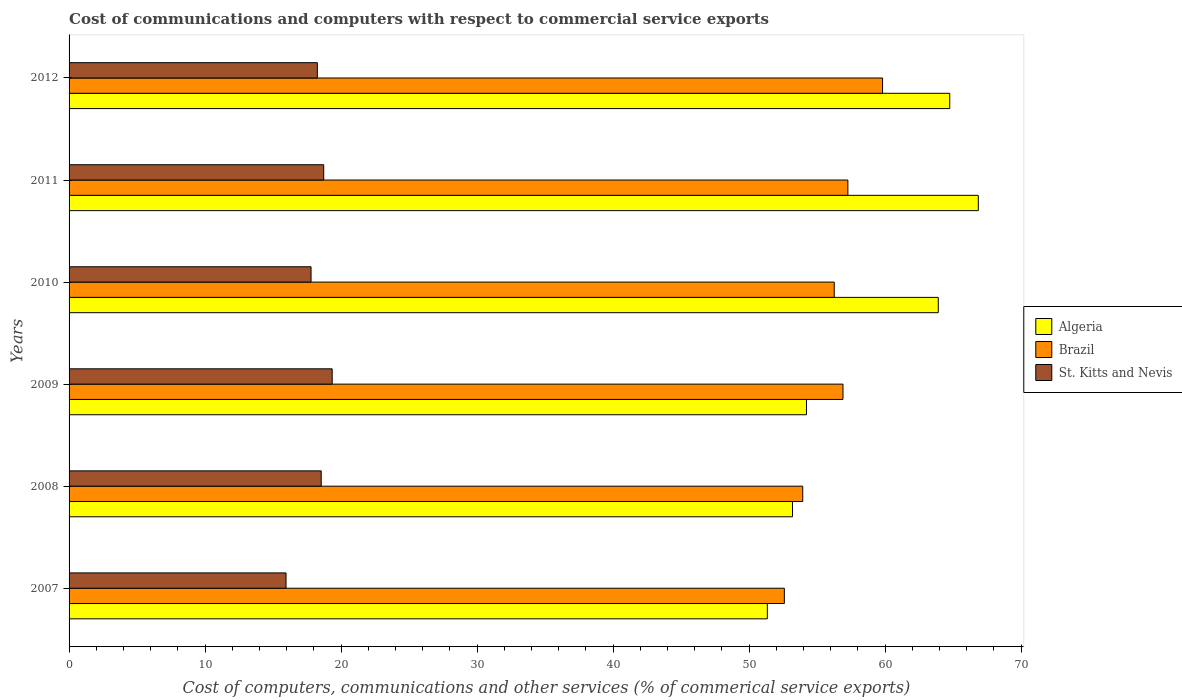How many groups of bars are there?
Ensure brevity in your answer.  6. How many bars are there on the 3rd tick from the bottom?
Make the answer very short. 3. What is the label of the 5th group of bars from the top?
Provide a short and direct response. 2008. What is the cost of communications and computers in St. Kitts and Nevis in 2011?
Your response must be concise. 18.72. Across all years, what is the maximum cost of communications and computers in Brazil?
Make the answer very short. 59.81. Across all years, what is the minimum cost of communications and computers in Brazil?
Your answer should be very brief. 52.59. What is the total cost of communications and computers in Brazil in the graph?
Give a very brief answer. 336.75. What is the difference between the cost of communications and computers in Algeria in 2007 and that in 2012?
Your answer should be very brief. -13.41. What is the difference between the cost of communications and computers in Algeria in 2011 and the cost of communications and computers in St. Kitts and Nevis in 2008?
Your answer should be very brief. 48.31. What is the average cost of communications and computers in St. Kitts and Nevis per year?
Make the answer very short. 18.1. In the year 2010, what is the difference between the cost of communications and computers in Brazil and cost of communications and computers in St. Kitts and Nevis?
Provide a short and direct response. 38.46. In how many years, is the cost of communications and computers in St. Kitts and Nevis greater than 60 %?
Your answer should be compact. 0. What is the ratio of the cost of communications and computers in St. Kitts and Nevis in 2008 to that in 2010?
Keep it short and to the point. 1.04. Is the cost of communications and computers in Algeria in 2010 less than that in 2012?
Make the answer very short. Yes. Is the difference between the cost of communications and computers in Brazil in 2007 and 2009 greater than the difference between the cost of communications and computers in St. Kitts and Nevis in 2007 and 2009?
Offer a terse response. No. What is the difference between the highest and the second highest cost of communications and computers in St. Kitts and Nevis?
Your answer should be very brief. 0.62. What is the difference between the highest and the lowest cost of communications and computers in Brazil?
Keep it short and to the point. 7.22. In how many years, is the cost of communications and computers in Brazil greater than the average cost of communications and computers in Brazil taken over all years?
Provide a succinct answer. 4. Is the sum of the cost of communications and computers in Algeria in 2010 and 2012 greater than the maximum cost of communications and computers in St. Kitts and Nevis across all years?
Provide a succinct answer. Yes. What does the 3rd bar from the top in 2010 represents?
Offer a terse response. Algeria. What does the 1st bar from the bottom in 2009 represents?
Provide a short and direct response. Algeria. Is it the case that in every year, the sum of the cost of communications and computers in Brazil and cost of communications and computers in St. Kitts and Nevis is greater than the cost of communications and computers in Algeria?
Ensure brevity in your answer.  Yes. Are all the bars in the graph horizontal?
Give a very brief answer. Yes. Are the values on the major ticks of X-axis written in scientific E-notation?
Give a very brief answer. No. Does the graph contain any zero values?
Offer a terse response. No. Does the graph contain grids?
Your response must be concise. No. Where does the legend appear in the graph?
Your answer should be very brief. Center right. What is the title of the graph?
Your answer should be very brief. Cost of communications and computers with respect to commercial service exports. Does "Small states" appear as one of the legend labels in the graph?
Offer a terse response. No. What is the label or title of the X-axis?
Give a very brief answer. Cost of computers, communications and other services (% of commerical service exports). What is the label or title of the Y-axis?
Keep it short and to the point. Years. What is the Cost of computers, communications and other services (% of commerical service exports) in Algeria in 2007?
Offer a terse response. 51.34. What is the Cost of computers, communications and other services (% of commerical service exports) in Brazil in 2007?
Offer a terse response. 52.59. What is the Cost of computers, communications and other services (% of commerical service exports) in St. Kitts and Nevis in 2007?
Provide a succinct answer. 15.95. What is the Cost of computers, communications and other services (% of commerical service exports) of Algeria in 2008?
Keep it short and to the point. 53.19. What is the Cost of computers, communications and other services (% of commerical service exports) in Brazil in 2008?
Offer a very short reply. 53.94. What is the Cost of computers, communications and other services (% of commerical service exports) in St. Kitts and Nevis in 2008?
Give a very brief answer. 18.54. What is the Cost of computers, communications and other services (% of commerical service exports) of Algeria in 2009?
Your answer should be very brief. 54.21. What is the Cost of computers, communications and other services (% of commerical service exports) of Brazil in 2009?
Ensure brevity in your answer.  56.9. What is the Cost of computers, communications and other services (% of commerical service exports) in St. Kitts and Nevis in 2009?
Your response must be concise. 19.34. What is the Cost of computers, communications and other services (% of commerical service exports) of Algeria in 2010?
Keep it short and to the point. 63.9. What is the Cost of computers, communications and other services (% of commerical service exports) of Brazil in 2010?
Provide a short and direct response. 56.25. What is the Cost of computers, communications and other services (% of commerical service exports) in St. Kitts and Nevis in 2010?
Provide a succinct answer. 17.79. What is the Cost of computers, communications and other services (% of commerical service exports) in Algeria in 2011?
Your answer should be very brief. 66.85. What is the Cost of computers, communications and other services (% of commerical service exports) of Brazil in 2011?
Your answer should be very brief. 57.26. What is the Cost of computers, communications and other services (% of commerical service exports) in St. Kitts and Nevis in 2011?
Your response must be concise. 18.72. What is the Cost of computers, communications and other services (% of commerical service exports) in Algeria in 2012?
Your response must be concise. 64.75. What is the Cost of computers, communications and other services (% of commerical service exports) of Brazil in 2012?
Provide a succinct answer. 59.81. What is the Cost of computers, communications and other services (% of commerical service exports) in St. Kitts and Nevis in 2012?
Provide a short and direct response. 18.25. Across all years, what is the maximum Cost of computers, communications and other services (% of commerical service exports) in Algeria?
Ensure brevity in your answer.  66.85. Across all years, what is the maximum Cost of computers, communications and other services (% of commerical service exports) in Brazil?
Offer a terse response. 59.81. Across all years, what is the maximum Cost of computers, communications and other services (% of commerical service exports) in St. Kitts and Nevis?
Your answer should be very brief. 19.34. Across all years, what is the minimum Cost of computers, communications and other services (% of commerical service exports) in Algeria?
Make the answer very short. 51.34. Across all years, what is the minimum Cost of computers, communications and other services (% of commerical service exports) of Brazil?
Offer a terse response. 52.59. Across all years, what is the minimum Cost of computers, communications and other services (% of commerical service exports) of St. Kitts and Nevis?
Keep it short and to the point. 15.95. What is the total Cost of computers, communications and other services (% of commerical service exports) in Algeria in the graph?
Keep it short and to the point. 354.23. What is the total Cost of computers, communications and other services (% of commerical service exports) of Brazil in the graph?
Give a very brief answer. 336.75. What is the total Cost of computers, communications and other services (% of commerical service exports) of St. Kitts and Nevis in the graph?
Provide a short and direct response. 108.6. What is the difference between the Cost of computers, communications and other services (% of commerical service exports) of Algeria in 2007 and that in 2008?
Make the answer very short. -1.85. What is the difference between the Cost of computers, communications and other services (% of commerical service exports) of Brazil in 2007 and that in 2008?
Offer a very short reply. -1.35. What is the difference between the Cost of computers, communications and other services (% of commerical service exports) of St. Kitts and Nevis in 2007 and that in 2008?
Ensure brevity in your answer.  -2.59. What is the difference between the Cost of computers, communications and other services (% of commerical service exports) in Algeria in 2007 and that in 2009?
Give a very brief answer. -2.88. What is the difference between the Cost of computers, communications and other services (% of commerical service exports) of Brazil in 2007 and that in 2009?
Ensure brevity in your answer.  -4.31. What is the difference between the Cost of computers, communications and other services (% of commerical service exports) in St. Kitts and Nevis in 2007 and that in 2009?
Provide a succinct answer. -3.39. What is the difference between the Cost of computers, communications and other services (% of commerical service exports) in Algeria in 2007 and that in 2010?
Make the answer very short. -12.57. What is the difference between the Cost of computers, communications and other services (% of commerical service exports) of Brazil in 2007 and that in 2010?
Give a very brief answer. -3.67. What is the difference between the Cost of computers, communications and other services (% of commerical service exports) in St. Kitts and Nevis in 2007 and that in 2010?
Offer a very short reply. -1.84. What is the difference between the Cost of computers, communications and other services (% of commerical service exports) in Algeria in 2007 and that in 2011?
Your answer should be compact. -15.51. What is the difference between the Cost of computers, communications and other services (% of commerical service exports) in Brazil in 2007 and that in 2011?
Provide a short and direct response. -4.67. What is the difference between the Cost of computers, communications and other services (% of commerical service exports) of St. Kitts and Nevis in 2007 and that in 2011?
Provide a short and direct response. -2.77. What is the difference between the Cost of computers, communications and other services (% of commerical service exports) of Algeria in 2007 and that in 2012?
Offer a very short reply. -13.41. What is the difference between the Cost of computers, communications and other services (% of commerical service exports) of Brazil in 2007 and that in 2012?
Keep it short and to the point. -7.22. What is the difference between the Cost of computers, communications and other services (% of commerical service exports) of St. Kitts and Nevis in 2007 and that in 2012?
Keep it short and to the point. -2.3. What is the difference between the Cost of computers, communications and other services (% of commerical service exports) in Algeria in 2008 and that in 2009?
Your answer should be compact. -1.03. What is the difference between the Cost of computers, communications and other services (% of commerical service exports) of Brazil in 2008 and that in 2009?
Offer a very short reply. -2.96. What is the difference between the Cost of computers, communications and other services (% of commerical service exports) of St. Kitts and Nevis in 2008 and that in 2009?
Your answer should be compact. -0.81. What is the difference between the Cost of computers, communications and other services (% of commerical service exports) in Algeria in 2008 and that in 2010?
Give a very brief answer. -10.72. What is the difference between the Cost of computers, communications and other services (% of commerical service exports) of Brazil in 2008 and that in 2010?
Your answer should be compact. -2.32. What is the difference between the Cost of computers, communications and other services (% of commerical service exports) of St. Kitts and Nevis in 2008 and that in 2010?
Keep it short and to the point. 0.75. What is the difference between the Cost of computers, communications and other services (% of commerical service exports) in Algeria in 2008 and that in 2011?
Give a very brief answer. -13.66. What is the difference between the Cost of computers, communications and other services (% of commerical service exports) in Brazil in 2008 and that in 2011?
Ensure brevity in your answer.  -3.32. What is the difference between the Cost of computers, communications and other services (% of commerical service exports) of St. Kitts and Nevis in 2008 and that in 2011?
Your answer should be very brief. -0.18. What is the difference between the Cost of computers, communications and other services (% of commerical service exports) in Algeria in 2008 and that in 2012?
Your response must be concise. -11.56. What is the difference between the Cost of computers, communications and other services (% of commerical service exports) in Brazil in 2008 and that in 2012?
Ensure brevity in your answer.  -5.87. What is the difference between the Cost of computers, communications and other services (% of commerical service exports) of St. Kitts and Nevis in 2008 and that in 2012?
Give a very brief answer. 0.29. What is the difference between the Cost of computers, communications and other services (% of commerical service exports) of Algeria in 2009 and that in 2010?
Your answer should be compact. -9.69. What is the difference between the Cost of computers, communications and other services (% of commerical service exports) in Brazil in 2009 and that in 2010?
Your answer should be compact. 0.64. What is the difference between the Cost of computers, communications and other services (% of commerical service exports) of St. Kitts and Nevis in 2009 and that in 2010?
Offer a very short reply. 1.55. What is the difference between the Cost of computers, communications and other services (% of commerical service exports) of Algeria in 2009 and that in 2011?
Offer a terse response. -12.63. What is the difference between the Cost of computers, communications and other services (% of commerical service exports) in Brazil in 2009 and that in 2011?
Offer a terse response. -0.36. What is the difference between the Cost of computers, communications and other services (% of commerical service exports) in St. Kitts and Nevis in 2009 and that in 2011?
Give a very brief answer. 0.62. What is the difference between the Cost of computers, communications and other services (% of commerical service exports) of Algeria in 2009 and that in 2012?
Make the answer very short. -10.53. What is the difference between the Cost of computers, communications and other services (% of commerical service exports) in Brazil in 2009 and that in 2012?
Offer a terse response. -2.91. What is the difference between the Cost of computers, communications and other services (% of commerical service exports) in St. Kitts and Nevis in 2009 and that in 2012?
Your answer should be compact. 1.09. What is the difference between the Cost of computers, communications and other services (% of commerical service exports) in Algeria in 2010 and that in 2011?
Your answer should be very brief. -2.94. What is the difference between the Cost of computers, communications and other services (% of commerical service exports) in Brazil in 2010 and that in 2011?
Keep it short and to the point. -1. What is the difference between the Cost of computers, communications and other services (% of commerical service exports) in St. Kitts and Nevis in 2010 and that in 2011?
Offer a very short reply. -0.93. What is the difference between the Cost of computers, communications and other services (% of commerical service exports) of Algeria in 2010 and that in 2012?
Your response must be concise. -0.84. What is the difference between the Cost of computers, communications and other services (% of commerical service exports) in Brazil in 2010 and that in 2012?
Your answer should be compact. -3.55. What is the difference between the Cost of computers, communications and other services (% of commerical service exports) in St. Kitts and Nevis in 2010 and that in 2012?
Keep it short and to the point. -0.46. What is the difference between the Cost of computers, communications and other services (% of commerical service exports) in Algeria in 2011 and that in 2012?
Your answer should be very brief. 2.1. What is the difference between the Cost of computers, communications and other services (% of commerical service exports) of Brazil in 2011 and that in 2012?
Offer a very short reply. -2.55. What is the difference between the Cost of computers, communications and other services (% of commerical service exports) in St. Kitts and Nevis in 2011 and that in 2012?
Your answer should be compact. 0.47. What is the difference between the Cost of computers, communications and other services (% of commerical service exports) in Algeria in 2007 and the Cost of computers, communications and other services (% of commerical service exports) in Brazil in 2008?
Keep it short and to the point. -2.6. What is the difference between the Cost of computers, communications and other services (% of commerical service exports) of Algeria in 2007 and the Cost of computers, communications and other services (% of commerical service exports) of St. Kitts and Nevis in 2008?
Ensure brevity in your answer.  32.8. What is the difference between the Cost of computers, communications and other services (% of commerical service exports) in Brazil in 2007 and the Cost of computers, communications and other services (% of commerical service exports) in St. Kitts and Nevis in 2008?
Provide a succinct answer. 34.05. What is the difference between the Cost of computers, communications and other services (% of commerical service exports) in Algeria in 2007 and the Cost of computers, communications and other services (% of commerical service exports) in Brazil in 2009?
Give a very brief answer. -5.56. What is the difference between the Cost of computers, communications and other services (% of commerical service exports) of Algeria in 2007 and the Cost of computers, communications and other services (% of commerical service exports) of St. Kitts and Nevis in 2009?
Your answer should be very brief. 31.99. What is the difference between the Cost of computers, communications and other services (% of commerical service exports) of Brazil in 2007 and the Cost of computers, communications and other services (% of commerical service exports) of St. Kitts and Nevis in 2009?
Keep it short and to the point. 33.24. What is the difference between the Cost of computers, communications and other services (% of commerical service exports) in Algeria in 2007 and the Cost of computers, communications and other services (% of commerical service exports) in Brazil in 2010?
Make the answer very short. -4.92. What is the difference between the Cost of computers, communications and other services (% of commerical service exports) of Algeria in 2007 and the Cost of computers, communications and other services (% of commerical service exports) of St. Kitts and Nevis in 2010?
Provide a succinct answer. 33.55. What is the difference between the Cost of computers, communications and other services (% of commerical service exports) of Brazil in 2007 and the Cost of computers, communications and other services (% of commerical service exports) of St. Kitts and Nevis in 2010?
Ensure brevity in your answer.  34.8. What is the difference between the Cost of computers, communications and other services (% of commerical service exports) in Algeria in 2007 and the Cost of computers, communications and other services (% of commerical service exports) in Brazil in 2011?
Your answer should be very brief. -5.92. What is the difference between the Cost of computers, communications and other services (% of commerical service exports) in Algeria in 2007 and the Cost of computers, communications and other services (% of commerical service exports) in St. Kitts and Nevis in 2011?
Make the answer very short. 32.61. What is the difference between the Cost of computers, communications and other services (% of commerical service exports) of Brazil in 2007 and the Cost of computers, communications and other services (% of commerical service exports) of St. Kitts and Nevis in 2011?
Your response must be concise. 33.87. What is the difference between the Cost of computers, communications and other services (% of commerical service exports) in Algeria in 2007 and the Cost of computers, communications and other services (% of commerical service exports) in Brazil in 2012?
Provide a short and direct response. -8.47. What is the difference between the Cost of computers, communications and other services (% of commerical service exports) of Algeria in 2007 and the Cost of computers, communications and other services (% of commerical service exports) of St. Kitts and Nevis in 2012?
Offer a very short reply. 33.08. What is the difference between the Cost of computers, communications and other services (% of commerical service exports) of Brazil in 2007 and the Cost of computers, communications and other services (% of commerical service exports) of St. Kitts and Nevis in 2012?
Your response must be concise. 34.34. What is the difference between the Cost of computers, communications and other services (% of commerical service exports) of Algeria in 2008 and the Cost of computers, communications and other services (% of commerical service exports) of Brazil in 2009?
Your answer should be compact. -3.71. What is the difference between the Cost of computers, communications and other services (% of commerical service exports) of Algeria in 2008 and the Cost of computers, communications and other services (% of commerical service exports) of St. Kitts and Nevis in 2009?
Make the answer very short. 33.84. What is the difference between the Cost of computers, communications and other services (% of commerical service exports) in Brazil in 2008 and the Cost of computers, communications and other services (% of commerical service exports) in St. Kitts and Nevis in 2009?
Offer a very short reply. 34.6. What is the difference between the Cost of computers, communications and other services (% of commerical service exports) in Algeria in 2008 and the Cost of computers, communications and other services (% of commerical service exports) in Brazil in 2010?
Ensure brevity in your answer.  -3.07. What is the difference between the Cost of computers, communications and other services (% of commerical service exports) in Algeria in 2008 and the Cost of computers, communications and other services (% of commerical service exports) in St. Kitts and Nevis in 2010?
Offer a terse response. 35.4. What is the difference between the Cost of computers, communications and other services (% of commerical service exports) in Brazil in 2008 and the Cost of computers, communications and other services (% of commerical service exports) in St. Kitts and Nevis in 2010?
Offer a terse response. 36.15. What is the difference between the Cost of computers, communications and other services (% of commerical service exports) of Algeria in 2008 and the Cost of computers, communications and other services (% of commerical service exports) of Brazil in 2011?
Offer a very short reply. -4.07. What is the difference between the Cost of computers, communications and other services (% of commerical service exports) in Algeria in 2008 and the Cost of computers, communications and other services (% of commerical service exports) in St. Kitts and Nevis in 2011?
Provide a short and direct response. 34.46. What is the difference between the Cost of computers, communications and other services (% of commerical service exports) of Brazil in 2008 and the Cost of computers, communications and other services (% of commerical service exports) of St. Kitts and Nevis in 2011?
Offer a very short reply. 35.22. What is the difference between the Cost of computers, communications and other services (% of commerical service exports) in Algeria in 2008 and the Cost of computers, communications and other services (% of commerical service exports) in Brazil in 2012?
Keep it short and to the point. -6.62. What is the difference between the Cost of computers, communications and other services (% of commerical service exports) of Algeria in 2008 and the Cost of computers, communications and other services (% of commerical service exports) of St. Kitts and Nevis in 2012?
Keep it short and to the point. 34.93. What is the difference between the Cost of computers, communications and other services (% of commerical service exports) of Brazil in 2008 and the Cost of computers, communications and other services (% of commerical service exports) of St. Kitts and Nevis in 2012?
Your response must be concise. 35.69. What is the difference between the Cost of computers, communications and other services (% of commerical service exports) in Algeria in 2009 and the Cost of computers, communications and other services (% of commerical service exports) in Brazil in 2010?
Your answer should be compact. -2.04. What is the difference between the Cost of computers, communications and other services (% of commerical service exports) of Algeria in 2009 and the Cost of computers, communications and other services (% of commerical service exports) of St. Kitts and Nevis in 2010?
Your answer should be compact. 36.42. What is the difference between the Cost of computers, communications and other services (% of commerical service exports) of Brazil in 2009 and the Cost of computers, communications and other services (% of commerical service exports) of St. Kitts and Nevis in 2010?
Provide a short and direct response. 39.11. What is the difference between the Cost of computers, communications and other services (% of commerical service exports) of Algeria in 2009 and the Cost of computers, communications and other services (% of commerical service exports) of Brazil in 2011?
Offer a very short reply. -3.04. What is the difference between the Cost of computers, communications and other services (% of commerical service exports) in Algeria in 2009 and the Cost of computers, communications and other services (% of commerical service exports) in St. Kitts and Nevis in 2011?
Your answer should be very brief. 35.49. What is the difference between the Cost of computers, communications and other services (% of commerical service exports) in Brazil in 2009 and the Cost of computers, communications and other services (% of commerical service exports) in St. Kitts and Nevis in 2011?
Make the answer very short. 38.18. What is the difference between the Cost of computers, communications and other services (% of commerical service exports) of Algeria in 2009 and the Cost of computers, communications and other services (% of commerical service exports) of Brazil in 2012?
Your answer should be compact. -5.6. What is the difference between the Cost of computers, communications and other services (% of commerical service exports) of Algeria in 2009 and the Cost of computers, communications and other services (% of commerical service exports) of St. Kitts and Nevis in 2012?
Offer a very short reply. 35.96. What is the difference between the Cost of computers, communications and other services (% of commerical service exports) in Brazil in 2009 and the Cost of computers, communications and other services (% of commerical service exports) in St. Kitts and Nevis in 2012?
Your answer should be compact. 38.65. What is the difference between the Cost of computers, communications and other services (% of commerical service exports) of Algeria in 2010 and the Cost of computers, communications and other services (% of commerical service exports) of Brazil in 2011?
Give a very brief answer. 6.65. What is the difference between the Cost of computers, communications and other services (% of commerical service exports) of Algeria in 2010 and the Cost of computers, communications and other services (% of commerical service exports) of St. Kitts and Nevis in 2011?
Ensure brevity in your answer.  45.18. What is the difference between the Cost of computers, communications and other services (% of commerical service exports) in Brazil in 2010 and the Cost of computers, communications and other services (% of commerical service exports) in St. Kitts and Nevis in 2011?
Provide a succinct answer. 37.53. What is the difference between the Cost of computers, communications and other services (% of commerical service exports) of Algeria in 2010 and the Cost of computers, communications and other services (% of commerical service exports) of Brazil in 2012?
Offer a terse response. 4.1. What is the difference between the Cost of computers, communications and other services (% of commerical service exports) in Algeria in 2010 and the Cost of computers, communications and other services (% of commerical service exports) in St. Kitts and Nevis in 2012?
Your answer should be very brief. 45.65. What is the difference between the Cost of computers, communications and other services (% of commerical service exports) of Brazil in 2010 and the Cost of computers, communications and other services (% of commerical service exports) of St. Kitts and Nevis in 2012?
Your answer should be compact. 38. What is the difference between the Cost of computers, communications and other services (% of commerical service exports) in Algeria in 2011 and the Cost of computers, communications and other services (% of commerical service exports) in Brazil in 2012?
Make the answer very short. 7.04. What is the difference between the Cost of computers, communications and other services (% of commerical service exports) in Algeria in 2011 and the Cost of computers, communications and other services (% of commerical service exports) in St. Kitts and Nevis in 2012?
Give a very brief answer. 48.6. What is the difference between the Cost of computers, communications and other services (% of commerical service exports) of Brazil in 2011 and the Cost of computers, communications and other services (% of commerical service exports) of St. Kitts and Nevis in 2012?
Your answer should be very brief. 39.01. What is the average Cost of computers, communications and other services (% of commerical service exports) in Algeria per year?
Offer a terse response. 59.04. What is the average Cost of computers, communications and other services (% of commerical service exports) in Brazil per year?
Ensure brevity in your answer.  56.12. What is the average Cost of computers, communications and other services (% of commerical service exports) of St. Kitts and Nevis per year?
Give a very brief answer. 18.1. In the year 2007, what is the difference between the Cost of computers, communications and other services (% of commerical service exports) in Algeria and Cost of computers, communications and other services (% of commerical service exports) in Brazil?
Make the answer very short. -1.25. In the year 2007, what is the difference between the Cost of computers, communications and other services (% of commerical service exports) of Algeria and Cost of computers, communications and other services (% of commerical service exports) of St. Kitts and Nevis?
Provide a short and direct response. 35.38. In the year 2007, what is the difference between the Cost of computers, communications and other services (% of commerical service exports) in Brazil and Cost of computers, communications and other services (% of commerical service exports) in St. Kitts and Nevis?
Offer a very short reply. 36.64. In the year 2008, what is the difference between the Cost of computers, communications and other services (% of commerical service exports) of Algeria and Cost of computers, communications and other services (% of commerical service exports) of Brazil?
Make the answer very short. -0.75. In the year 2008, what is the difference between the Cost of computers, communications and other services (% of commerical service exports) in Algeria and Cost of computers, communications and other services (% of commerical service exports) in St. Kitts and Nevis?
Your answer should be compact. 34.65. In the year 2008, what is the difference between the Cost of computers, communications and other services (% of commerical service exports) of Brazil and Cost of computers, communications and other services (% of commerical service exports) of St. Kitts and Nevis?
Provide a short and direct response. 35.4. In the year 2009, what is the difference between the Cost of computers, communications and other services (% of commerical service exports) in Algeria and Cost of computers, communications and other services (% of commerical service exports) in Brazil?
Offer a terse response. -2.69. In the year 2009, what is the difference between the Cost of computers, communications and other services (% of commerical service exports) of Algeria and Cost of computers, communications and other services (% of commerical service exports) of St. Kitts and Nevis?
Keep it short and to the point. 34.87. In the year 2009, what is the difference between the Cost of computers, communications and other services (% of commerical service exports) in Brazil and Cost of computers, communications and other services (% of commerical service exports) in St. Kitts and Nevis?
Your response must be concise. 37.56. In the year 2010, what is the difference between the Cost of computers, communications and other services (% of commerical service exports) in Algeria and Cost of computers, communications and other services (% of commerical service exports) in Brazil?
Ensure brevity in your answer.  7.65. In the year 2010, what is the difference between the Cost of computers, communications and other services (% of commerical service exports) of Algeria and Cost of computers, communications and other services (% of commerical service exports) of St. Kitts and Nevis?
Ensure brevity in your answer.  46.11. In the year 2010, what is the difference between the Cost of computers, communications and other services (% of commerical service exports) in Brazil and Cost of computers, communications and other services (% of commerical service exports) in St. Kitts and Nevis?
Make the answer very short. 38.46. In the year 2011, what is the difference between the Cost of computers, communications and other services (% of commerical service exports) of Algeria and Cost of computers, communications and other services (% of commerical service exports) of Brazil?
Offer a very short reply. 9.59. In the year 2011, what is the difference between the Cost of computers, communications and other services (% of commerical service exports) in Algeria and Cost of computers, communications and other services (% of commerical service exports) in St. Kitts and Nevis?
Offer a terse response. 48.13. In the year 2011, what is the difference between the Cost of computers, communications and other services (% of commerical service exports) of Brazil and Cost of computers, communications and other services (% of commerical service exports) of St. Kitts and Nevis?
Offer a very short reply. 38.54. In the year 2012, what is the difference between the Cost of computers, communications and other services (% of commerical service exports) of Algeria and Cost of computers, communications and other services (% of commerical service exports) of Brazil?
Your answer should be very brief. 4.94. In the year 2012, what is the difference between the Cost of computers, communications and other services (% of commerical service exports) of Algeria and Cost of computers, communications and other services (% of commerical service exports) of St. Kitts and Nevis?
Your response must be concise. 46.49. In the year 2012, what is the difference between the Cost of computers, communications and other services (% of commerical service exports) in Brazil and Cost of computers, communications and other services (% of commerical service exports) in St. Kitts and Nevis?
Provide a short and direct response. 41.56. What is the ratio of the Cost of computers, communications and other services (% of commerical service exports) of Algeria in 2007 to that in 2008?
Keep it short and to the point. 0.97. What is the ratio of the Cost of computers, communications and other services (% of commerical service exports) in Brazil in 2007 to that in 2008?
Offer a very short reply. 0.97. What is the ratio of the Cost of computers, communications and other services (% of commerical service exports) in St. Kitts and Nevis in 2007 to that in 2008?
Give a very brief answer. 0.86. What is the ratio of the Cost of computers, communications and other services (% of commerical service exports) of Algeria in 2007 to that in 2009?
Offer a very short reply. 0.95. What is the ratio of the Cost of computers, communications and other services (% of commerical service exports) in Brazil in 2007 to that in 2009?
Provide a short and direct response. 0.92. What is the ratio of the Cost of computers, communications and other services (% of commerical service exports) in St. Kitts and Nevis in 2007 to that in 2009?
Provide a succinct answer. 0.82. What is the ratio of the Cost of computers, communications and other services (% of commerical service exports) in Algeria in 2007 to that in 2010?
Ensure brevity in your answer.  0.8. What is the ratio of the Cost of computers, communications and other services (% of commerical service exports) of Brazil in 2007 to that in 2010?
Ensure brevity in your answer.  0.93. What is the ratio of the Cost of computers, communications and other services (% of commerical service exports) in St. Kitts and Nevis in 2007 to that in 2010?
Offer a very short reply. 0.9. What is the ratio of the Cost of computers, communications and other services (% of commerical service exports) of Algeria in 2007 to that in 2011?
Keep it short and to the point. 0.77. What is the ratio of the Cost of computers, communications and other services (% of commerical service exports) in Brazil in 2007 to that in 2011?
Offer a terse response. 0.92. What is the ratio of the Cost of computers, communications and other services (% of commerical service exports) of St. Kitts and Nevis in 2007 to that in 2011?
Offer a terse response. 0.85. What is the ratio of the Cost of computers, communications and other services (% of commerical service exports) of Algeria in 2007 to that in 2012?
Offer a very short reply. 0.79. What is the ratio of the Cost of computers, communications and other services (% of commerical service exports) of Brazil in 2007 to that in 2012?
Offer a very short reply. 0.88. What is the ratio of the Cost of computers, communications and other services (% of commerical service exports) in St. Kitts and Nevis in 2007 to that in 2012?
Your answer should be compact. 0.87. What is the ratio of the Cost of computers, communications and other services (% of commerical service exports) of Brazil in 2008 to that in 2009?
Keep it short and to the point. 0.95. What is the ratio of the Cost of computers, communications and other services (% of commerical service exports) in Algeria in 2008 to that in 2010?
Ensure brevity in your answer.  0.83. What is the ratio of the Cost of computers, communications and other services (% of commerical service exports) of Brazil in 2008 to that in 2010?
Your answer should be compact. 0.96. What is the ratio of the Cost of computers, communications and other services (% of commerical service exports) in St. Kitts and Nevis in 2008 to that in 2010?
Your answer should be compact. 1.04. What is the ratio of the Cost of computers, communications and other services (% of commerical service exports) of Algeria in 2008 to that in 2011?
Your response must be concise. 0.8. What is the ratio of the Cost of computers, communications and other services (% of commerical service exports) in Brazil in 2008 to that in 2011?
Keep it short and to the point. 0.94. What is the ratio of the Cost of computers, communications and other services (% of commerical service exports) in St. Kitts and Nevis in 2008 to that in 2011?
Your answer should be very brief. 0.99. What is the ratio of the Cost of computers, communications and other services (% of commerical service exports) of Algeria in 2008 to that in 2012?
Make the answer very short. 0.82. What is the ratio of the Cost of computers, communications and other services (% of commerical service exports) in Brazil in 2008 to that in 2012?
Your answer should be compact. 0.9. What is the ratio of the Cost of computers, communications and other services (% of commerical service exports) in St. Kitts and Nevis in 2008 to that in 2012?
Your response must be concise. 1.02. What is the ratio of the Cost of computers, communications and other services (% of commerical service exports) of Algeria in 2009 to that in 2010?
Ensure brevity in your answer.  0.85. What is the ratio of the Cost of computers, communications and other services (% of commerical service exports) in Brazil in 2009 to that in 2010?
Provide a short and direct response. 1.01. What is the ratio of the Cost of computers, communications and other services (% of commerical service exports) of St. Kitts and Nevis in 2009 to that in 2010?
Provide a succinct answer. 1.09. What is the ratio of the Cost of computers, communications and other services (% of commerical service exports) in Algeria in 2009 to that in 2011?
Your response must be concise. 0.81. What is the ratio of the Cost of computers, communications and other services (% of commerical service exports) in St. Kitts and Nevis in 2009 to that in 2011?
Keep it short and to the point. 1.03. What is the ratio of the Cost of computers, communications and other services (% of commerical service exports) in Algeria in 2009 to that in 2012?
Ensure brevity in your answer.  0.84. What is the ratio of the Cost of computers, communications and other services (% of commerical service exports) of Brazil in 2009 to that in 2012?
Give a very brief answer. 0.95. What is the ratio of the Cost of computers, communications and other services (% of commerical service exports) of St. Kitts and Nevis in 2009 to that in 2012?
Your answer should be very brief. 1.06. What is the ratio of the Cost of computers, communications and other services (% of commerical service exports) of Algeria in 2010 to that in 2011?
Make the answer very short. 0.96. What is the ratio of the Cost of computers, communications and other services (% of commerical service exports) of Brazil in 2010 to that in 2011?
Provide a succinct answer. 0.98. What is the ratio of the Cost of computers, communications and other services (% of commerical service exports) in St. Kitts and Nevis in 2010 to that in 2011?
Offer a terse response. 0.95. What is the ratio of the Cost of computers, communications and other services (% of commerical service exports) of Brazil in 2010 to that in 2012?
Your answer should be compact. 0.94. What is the ratio of the Cost of computers, communications and other services (% of commerical service exports) of St. Kitts and Nevis in 2010 to that in 2012?
Your answer should be very brief. 0.97. What is the ratio of the Cost of computers, communications and other services (% of commerical service exports) in Algeria in 2011 to that in 2012?
Offer a terse response. 1.03. What is the ratio of the Cost of computers, communications and other services (% of commerical service exports) in Brazil in 2011 to that in 2012?
Provide a short and direct response. 0.96. What is the ratio of the Cost of computers, communications and other services (% of commerical service exports) in St. Kitts and Nevis in 2011 to that in 2012?
Ensure brevity in your answer.  1.03. What is the difference between the highest and the second highest Cost of computers, communications and other services (% of commerical service exports) of Algeria?
Your answer should be very brief. 2.1. What is the difference between the highest and the second highest Cost of computers, communications and other services (% of commerical service exports) of Brazil?
Offer a very short reply. 2.55. What is the difference between the highest and the second highest Cost of computers, communications and other services (% of commerical service exports) of St. Kitts and Nevis?
Your answer should be very brief. 0.62. What is the difference between the highest and the lowest Cost of computers, communications and other services (% of commerical service exports) in Algeria?
Offer a terse response. 15.51. What is the difference between the highest and the lowest Cost of computers, communications and other services (% of commerical service exports) of Brazil?
Provide a short and direct response. 7.22. What is the difference between the highest and the lowest Cost of computers, communications and other services (% of commerical service exports) of St. Kitts and Nevis?
Your response must be concise. 3.39. 